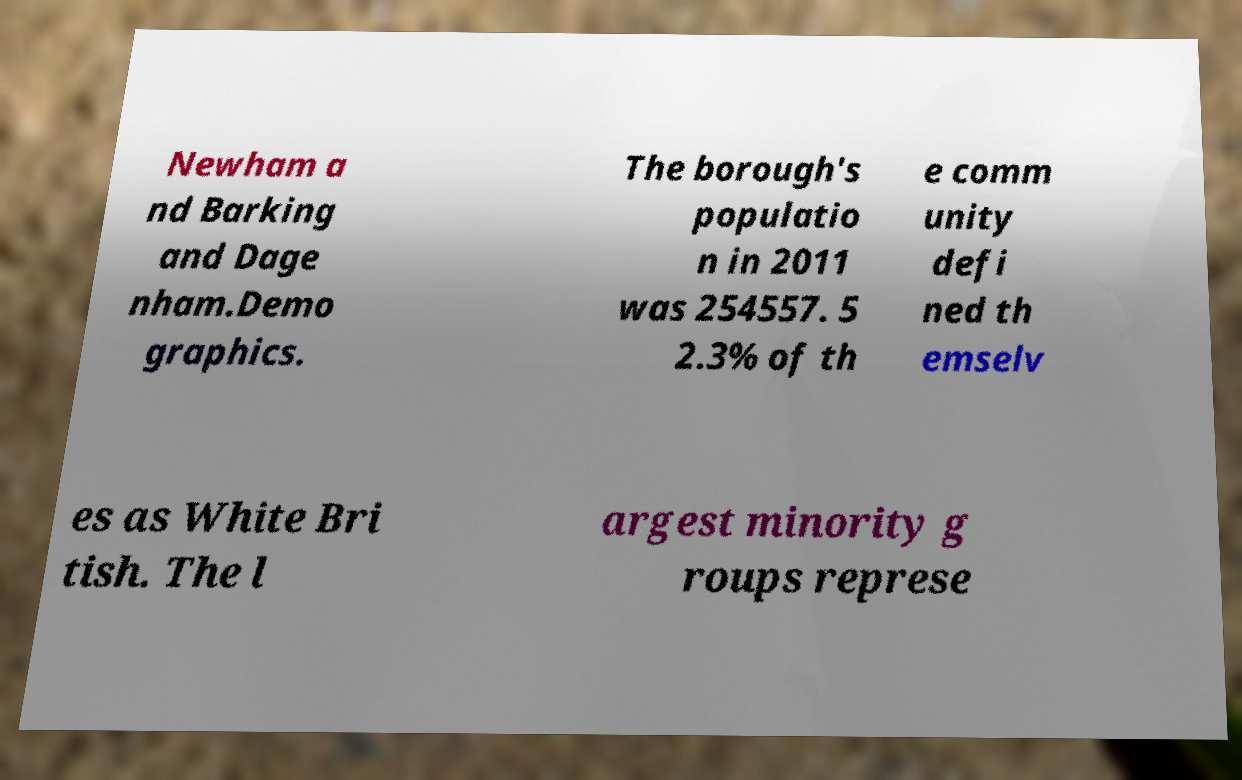Could you extract and type out the text from this image? Newham a nd Barking and Dage nham.Demo graphics. The borough's populatio n in 2011 was 254557. 5 2.3% of th e comm unity defi ned th emselv es as White Bri tish. The l argest minority g roups represe 